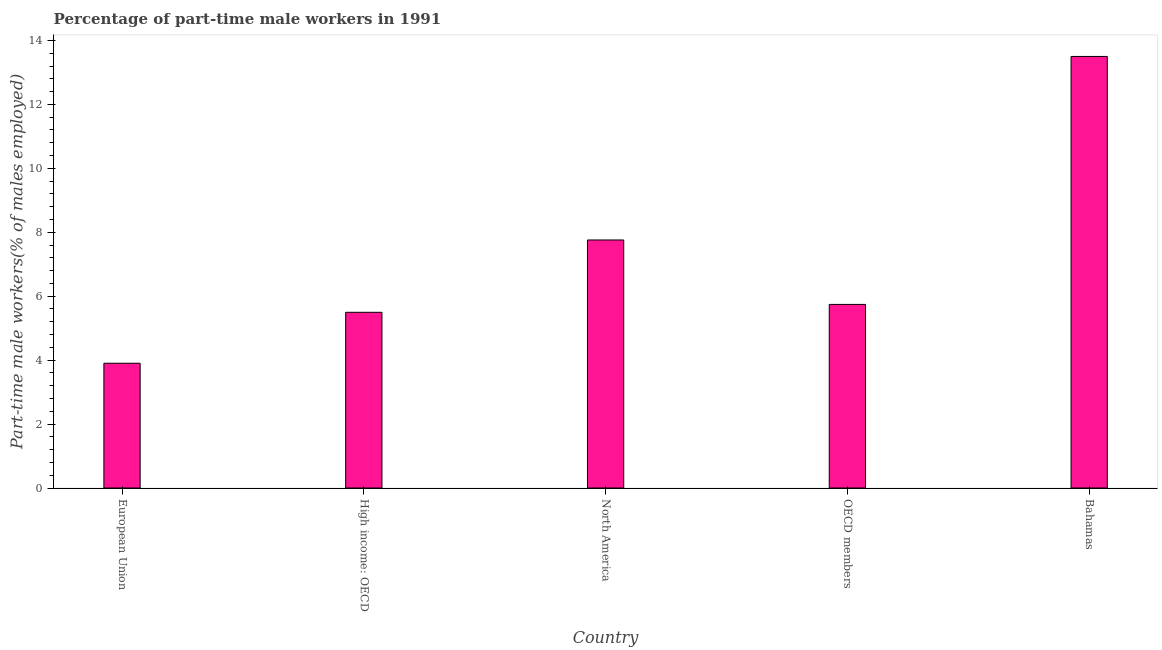What is the title of the graph?
Ensure brevity in your answer.  Percentage of part-time male workers in 1991. What is the label or title of the X-axis?
Provide a short and direct response. Country. What is the label or title of the Y-axis?
Offer a terse response. Part-time male workers(% of males employed). What is the percentage of part-time male workers in Bahamas?
Your response must be concise. 13.5. Across all countries, what is the maximum percentage of part-time male workers?
Your answer should be very brief. 13.5. Across all countries, what is the minimum percentage of part-time male workers?
Make the answer very short. 3.9. In which country was the percentage of part-time male workers maximum?
Provide a succinct answer. Bahamas. What is the sum of the percentage of part-time male workers?
Give a very brief answer. 36.4. What is the difference between the percentage of part-time male workers in Bahamas and OECD members?
Give a very brief answer. 7.76. What is the average percentage of part-time male workers per country?
Ensure brevity in your answer.  7.28. What is the median percentage of part-time male workers?
Your response must be concise. 5.74. What is the ratio of the percentage of part-time male workers in North America to that in OECD members?
Keep it short and to the point. 1.35. Is the percentage of part-time male workers in High income: OECD less than that in North America?
Offer a terse response. Yes. Is the difference between the percentage of part-time male workers in Bahamas and High income: OECD greater than the difference between any two countries?
Offer a terse response. No. What is the difference between the highest and the second highest percentage of part-time male workers?
Offer a terse response. 5.74. Is the sum of the percentage of part-time male workers in Bahamas and European Union greater than the maximum percentage of part-time male workers across all countries?
Your answer should be very brief. Yes. What is the difference between the highest and the lowest percentage of part-time male workers?
Your answer should be very brief. 9.6. How many bars are there?
Offer a very short reply. 5. Are all the bars in the graph horizontal?
Make the answer very short. No. How many countries are there in the graph?
Keep it short and to the point. 5. What is the difference between two consecutive major ticks on the Y-axis?
Your answer should be very brief. 2. Are the values on the major ticks of Y-axis written in scientific E-notation?
Ensure brevity in your answer.  No. What is the Part-time male workers(% of males employed) in European Union?
Make the answer very short. 3.9. What is the Part-time male workers(% of males employed) of High income: OECD?
Provide a succinct answer. 5.5. What is the Part-time male workers(% of males employed) in North America?
Ensure brevity in your answer.  7.76. What is the Part-time male workers(% of males employed) in OECD members?
Your response must be concise. 5.74. What is the difference between the Part-time male workers(% of males employed) in European Union and High income: OECD?
Provide a short and direct response. -1.59. What is the difference between the Part-time male workers(% of males employed) in European Union and North America?
Offer a very short reply. -3.86. What is the difference between the Part-time male workers(% of males employed) in European Union and OECD members?
Your answer should be very brief. -1.84. What is the difference between the Part-time male workers(% of males employed) in European Union and Bahamas?
Keep it short and to the point. -9.6. What is the difference between the Part-time male workers(% of males employed) in High income: OECD and North America?
Make the answer very short. -2.26. What is the difference between the Part-time male workers(% of males employed) in High income: OECD and OECD members?
Keep it short and to the point. -0.25. What is the difference between the Part-time male workers(% of males employed) in High income: OECD and Bahamas?
Your answer should be compact. -8. What is the difference between the Part-time male workers(% of males employed) in North America and OECD members?
Your answer should be compact. 2.02. What is the difference between the Part-time male workers(% of males employed) in North America and Bahamas?
Give a very brief answer. -5.74. What is the difference between the Part-time male workers(% of males employed) in OECD members and Bahamas?
Ensure brevity in your answer.  -7.76. What is the ratio of the Part-time male workers(% of males employed) in European Union to that in High income: OECD?
Provide a short and direct response. 0.71. What is the ratio of the Part-time male workers(% of males employed) in European Union to that in North America?
Your answer should be very brief. 0.5. What is the ratio of the Part-time male workers(% of males employed) in European Union to that in OECD members?
Offer a very short reply. 0.68. What is the ratio of the Part-time male workers(% of males employed) in European Union to that in Bahamas?
Make the answer very short. 0.29. What is the ratio of the Part-time male workers(% of males employed) in High income: OECD to that in North America?
Your answer should be compact. 0.71. What is the ratio of the Part-time male workers(% of males employed) in High income: OECD to that in Bahamas?
Provide a short and direct response. 0.41. What is the ratio of the Part-time male workers(% of males employed) in North America to that in OECD members?
Your answer should be very brief. 1.35. What is the ratio of the Part-time male workers(% of males employed) in North America to that in Bahamas?
Ensure brevity in your answer.  0.57. What is the ratio of the Part-time male workers(% of males employed) in OECD members to that in Bahamas?
Your answer should be very brief. 0.42. 